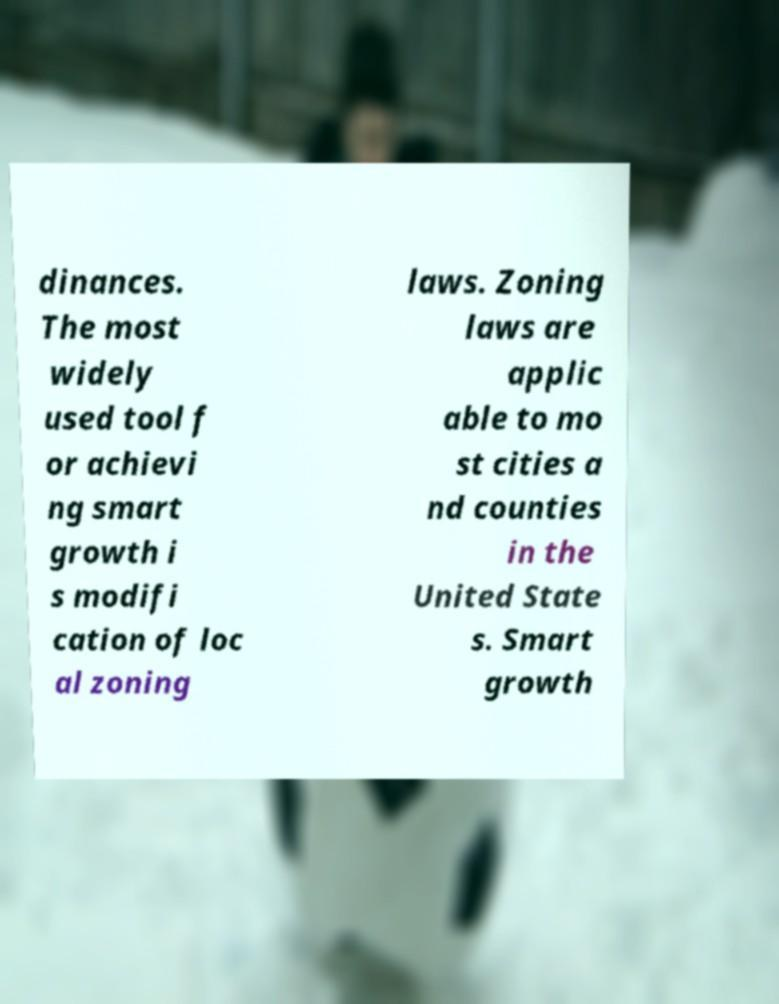Can you accurately transcribe the text from the provided image for me? dinances. The most widely used tool f or achievi ng smart growth i s modifi cation of loc al zoning laws. Zoning laws are applic able to mo st cities a nd counties in the United State s. Smart growth 